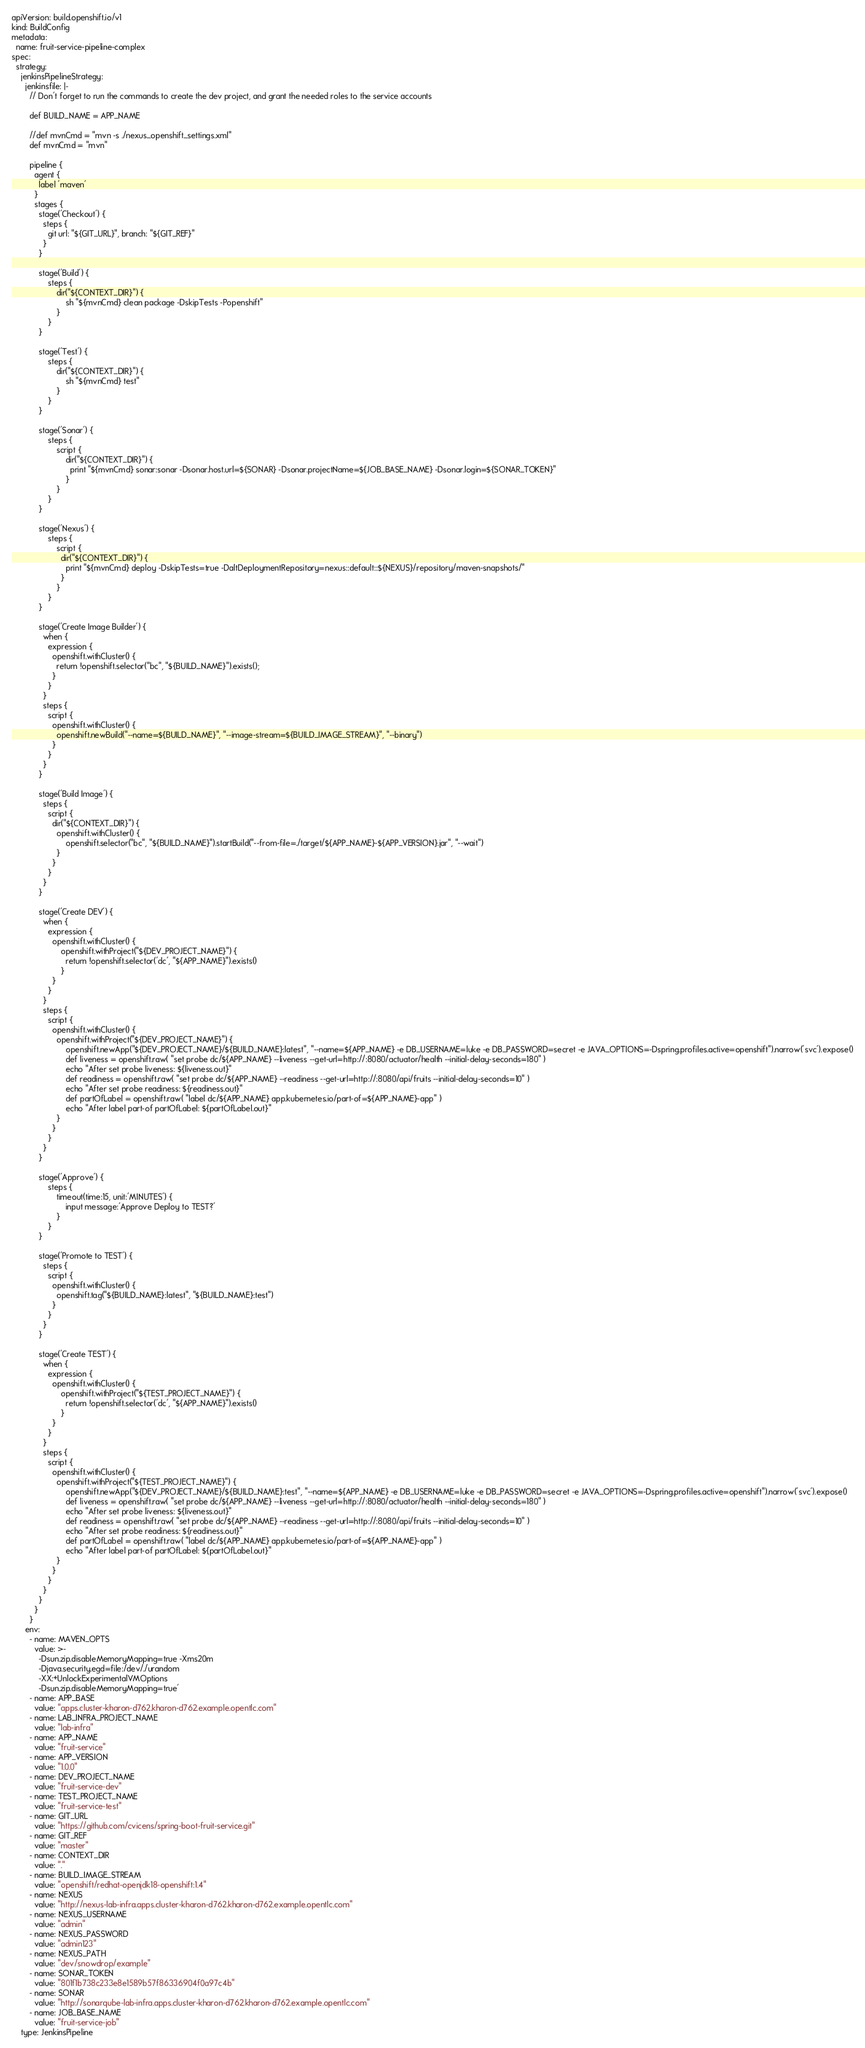<code> <loc_0><loc_0><loc_500><loc_500><_YAML_>apiVersion: build.openshift.io/v1
kind: BuildConfig
metadata:
  name: fruit-service-pipeline-complex
spec:
  strategy:
    jenkinsPipelineStrategy:
      jenkinsfile: |-
        // Don't forget to run the commands to create the dev project, and grant the needed roles to the service accounts
                
        def BUILD_NAME = APP_NAME
            
        //def mvnCmd = "mvn -s ./nexus_openshift_settings.xml"
        def mvnCmd = "mvn"

        pipeline {
          agent {
            label 'maven'
          }
          stages {
            stage('Checkout') {
              steps {
                git url: "${GIT_URL}", branch: "${GIT_REF}"
              }
            }
            
            stage('Build') {
                steps {
                    dir("${CONTEXT_DIR}") {
                        sh "${mvnCmd} clean package -DskipTests -Popenshift"
                    }
                }
            }
            
            stage('Test') {
                steps {
                    dir("${CONTEXT_DIR}") {
                        sh "${mvnCmd} test"
                    }
                }
            }
            
            stage('Sonar') {
                steps {
                    script {
                        dir("${CONTEXT_DIR}") {
                          print "${mvnCmd} sonar:sonar -Dsonar.host.url=${SONAR} -Dsonar.projectName=${JOB_BASE_NAME} -Dsonar.login=${SONAR_TOKEN}"
                        }
                    }
                }
            }
            
            stage('Nexus') {
                steps {
                    script {
                      dir("${CONTEXT_DIR}") {
                        print "${mvnCmd} deploy -DskipTests=true -DaltDeploymentRepository=nexus::default::${NEXUS}/repository/maven-snapshots/"
                      }
                    }
                }
            }
                                
            stage('Create Image Builder') {
              when {
                expression {
                  openshift.withCluster() {
                    return !openshift.selector("bc", "${BUILD_NAME}").exists();
                  }
                }
              }
              steps {
                script {
                  openshift.withCluster() {
                    openshift.newBuild("--name=${BUILD_NAME}", "--image-stream=${BUILD_IMAGE_STREAM}", "--binary")
                  }
                }
              }
            }

            stage('Build Image') {
              steps {
                script {
                  dir("${CONTEXT_DIR}") {
                    openshift.withCluster() {
                        openshift.selector("bc", "${BUILD_NAME}").startBuild("--from-file=./target/${APP_NAME}-${APP_VERSION}.jar", "--wait")
                    }      
                  }
                }
              }
            }

            stage('Create DEV') {
              when {
                expression {
                  openshift.withCluster() {
                      openshift.withProject("${DEV_PROJECT_NAME}") {
                        return !openshift.selector('dc', "${APP_NAME}").exists()
                      }
                  }
                }
              }
              steps {
                script {
                  openshift.withCluster() {
                    openshift.withProject("${DEV_PROJECT_NAME}") {
                        openshift.newApp("${DEV_PROJECT_NAME}/${BUILD_NAME}:latest", "--name=${APP_NAME} -e DB_USERNAME=luke -e DB_PASSWORD=secret -e JAVA_OPTIONS=-Dspring.profiles.active=openshift").narrow('svc').expose()
                        def liveness = openshift.raw( "set probe dc/${APP_NAME} --liveness --get-url=http://:8080/actuator/health --initial-delay-seconds=180" )
                        echo "After set probe liveness: ${liveness.out}"
                        def readiness = openshift.raw( "set probe dc/${APP_NAME} --readiness --get-url=http://:8080/api/fruits --initial-delay-seconds=10" )
                        echo "After set probe readiness: ${readiness.out}"
                        def partOfLabel = openshift.raw( "label dc/${APP_NAME} app.kubernetes.io/part-of=${APP_NAME}-app" )
                        echo "After label part-of partOfLabel: ${partOfLabel.out}"
                    }
                  }
                }
              }
            }

            stage('Approve') {
                steps {
                    timeout(time:15, unit:'MINUTES') {
                        input message:'Approve Deploy to TEST?'
                    }
                }
            }

            stage('Promote to TEST') {
              steps {
                script {
                  openshift.withCluster() {
                    openshift.tag("${BUILD_NAME}:latest", "${BUILD_NAME}:test")
                  }
                }
              }
            }

            stage('Create TEST') {
              when {
                expression {
                  openshift.withCluster() {
                      openshift.withProject("${TEST_PROJECT_NAME}") {
                        return !openshift.selector('dc', "${APP_NAME}").exists()
                      }
                  }
                }
              }
              steps {
                script {
                  openshift.withCluster() {
                    openshift.withProject("${TEST_PROJECT_NAME}") {
                        openshift.newApp("${DEV_PROJECT_NAME}/${BUILD_NAME}:test", "--name=${APP_NAME} -e DB_USERNAME=luke -e DB_PASSWORD=secret -e JAVA_OPTIONS=-Dspring.profiles.active=openshift").narrow('svc').expose()
                        def liveness = openshift.raw( "set probe dc/${APP_NAME} --liveness --get-url=http://:8080/actuator/health --initial-delay-seconds=180" )
                        echo "After set probe liveness: ${liveness.out}"
                        def readiness = openshift.raw( "set probe dc/${APP_NAME} --readiness --get-url=http://:8080/api/fruits --initial-delay-seconds=10" )
                        echo "After set probe readiness: ${readiness.out}"
                        def partOfLabel = openshift.raw( "label dc/${APP_NAME} app.kubernetes.io/part-of=${APP_NAME}-app" )
                        echo "After label part-of partOfLabel: ${partOfLabel.out}"
                    }
                  }
                }
              }
            }
          }
        }
      env:
        - name: MAVEN_OPTS
          value: >-
            -Dsun.zip.disableMemoryMapping=true -Xms20m
            -Djava.security.egd=file:/dev/./urandom
            -XX:+UnlockExperimentalVMOptions
            -Dsun.zip.disableMemoryMapping=true'
        - name: APP_BASE
          value: "apps.cluster-kharon-d762.kharon-d762.example.opentlc.com"
        - name: LAB_INFRA_PROJECT_NAME
          value: "lab-infra"
        - name: APP_NAME
          value: "fruit-service"
        - name: APP_VERSION
          value: "1.0.0"
        - name: DEV_PROJECT_NAME
          value: "fruit-service-dev"
        - name: TEST_PROJECT_NAME
          value: "fruit-service-test"
        - name: GIT_URL
          value: "https://github.com/cvicens/spring-boot-fruit-service.git"
        - name: GIT_REF
          value: "master"
        - name: CONTEXT_DIR
          value: "."
        - name: BUILD_IMAGE_STREAM
          value: "openshift/redhat-openjdk18-openshift:1.4"
        - name: NEXUS
          value: "http://nexus-lab-infra.apps.cluster-kharon-d762.kharon-d762.example.opentlc.com"
        - name: NEXUS_USERNAME
          value: "admin"
        - name: NEXUS_PASSWORD
          value: "admin123"
        - name: NEXUS_PATH
          value: "dev/snowdrop/example"
        - name: SONAR_TOKEN
          value: "801f1b738c233e8e1589b57f86336904f0a97c4b"
        - name: SONAR
          value: "http://sonarqube-lab-infra.apps.cluster-kharon-d762.kharon-d762.example.opentlc.com"
        - name: JOB_BASE_NAME
          value: "fruit-service-job"
    type: JenkinsPipeline
</code> 